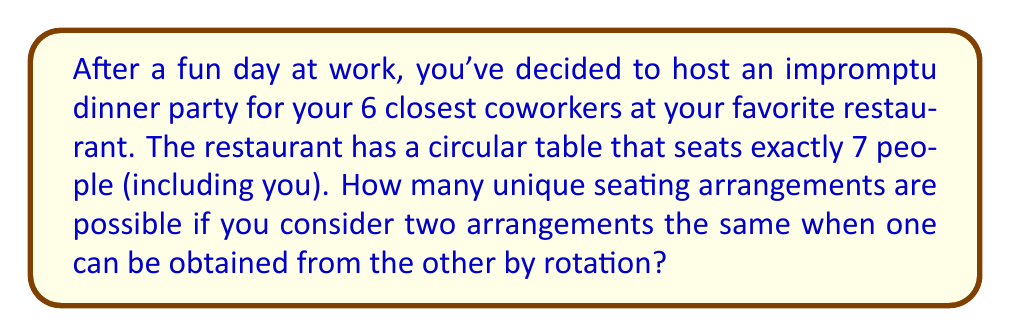Can you answer this question? Let's approach this step-by-step using concepts from permutation groups:

1) First, if the table were linear, we would have 7! = 5040 possible arrangements.

2) However, the table is circular, which means rotations of the same arrangement are considered identical. This is where we use the concept of cyclic groups.

3) In a circular arrangement, there are 7 possible rotations of each unique arrangement (including the original arrangement). This forms a cyclic group of order 7.

4) Therefore, we need to divide the total number of linear arrangements by the number of elements in this cyclic group.

5) The number of unique circular arrangements is given by:

   $$\frac{7!}{7} = \frac{5040}{7} = 720$$

6) This result can also be thought of as $(7-1)! = 6! = 720$, which is a general formula for the number of unique circular permutations of $n$ objects.

7) The mathematical reasoning behind this is that we can fix one person (say, yourself as the host) in one position, and then arrange the other 6 people in 6! ways.

This problem demonstrates the application of group theory in solving real-world combinatorial problems, specifically how the properties of cyclic groups can be used to count unique circular arrangements.
Answer: There are 720 unique seating arrangements possible. 